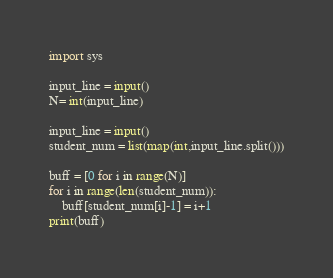<code> <loc_0><loc_0><loc_500><loc_500><_Python_>import sys

input_line = input()
N= int(input_line)

input_line = input()
student_num = list(map(int,input_line.split()))

buff = [0 for i in range(N)]
for i in range(len(student_num)):
    buff[student_num[i]-1] = i+1
print(buff)</code> 